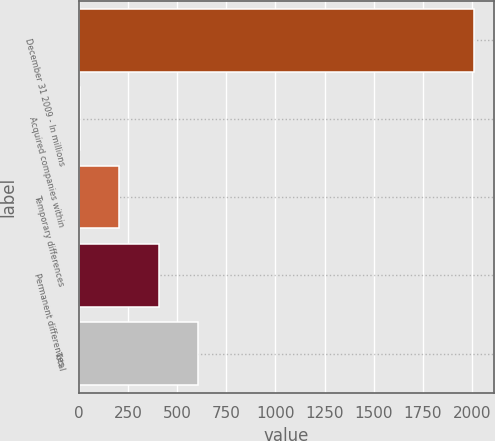Convert chart to OTSL. <chart><loc_0><loc_0><loc_500><loc_500><bar_chart><fcel>December 31 2009 - In millions<fcel>Acquired companies within<fcel>Temporary differences<fcel>Permanent differences<fcel>Total<nl><fcel>2009<fcel>5<fcel>205.4<fcel>405.8<fcel>606.2<nl></chart> 